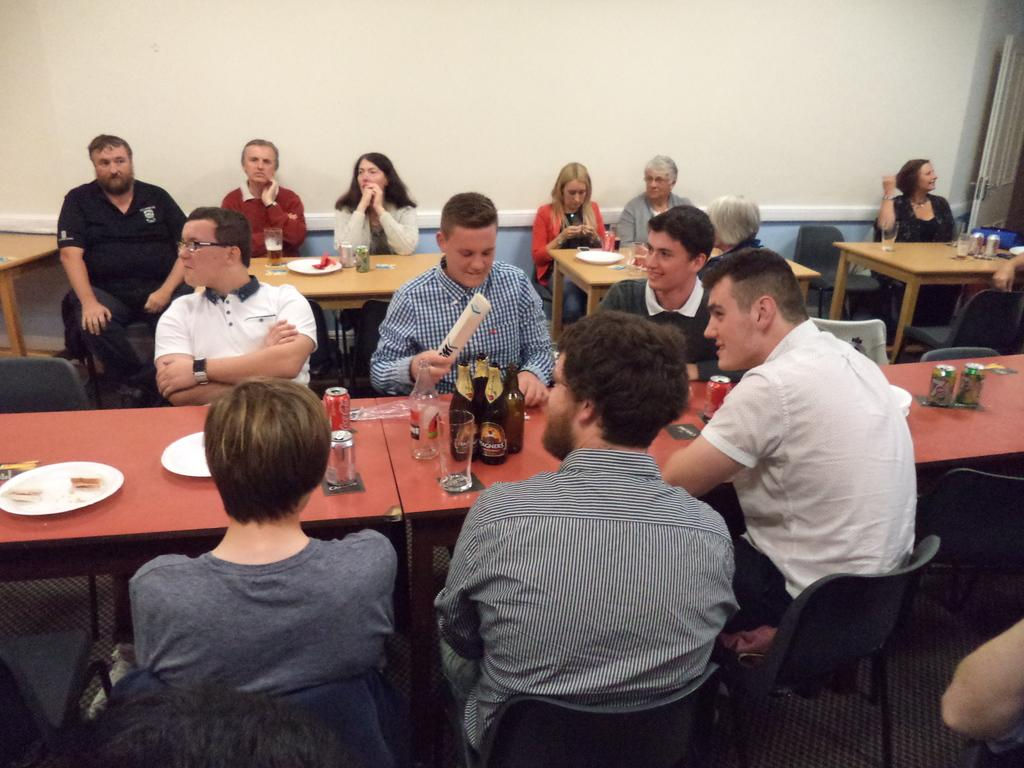What are the people in the image doing? The people in the image are sitting on chairs. Where are the chairs located in relation to each other? The chairs are around a table. What can be seen on the table in the image? There are wine bottles, glasses, and plates on the table. What type of scientific experiment is being conducted on the table in the image? There is no scientific experiment present in the image; it features people sitting around a table with wine bottles, glasses, and plates. Can you tell me how many yokes are visible on the table in the image? There are no yokes present in the image; it only features wine bottles, glasses, and plates on the table. 